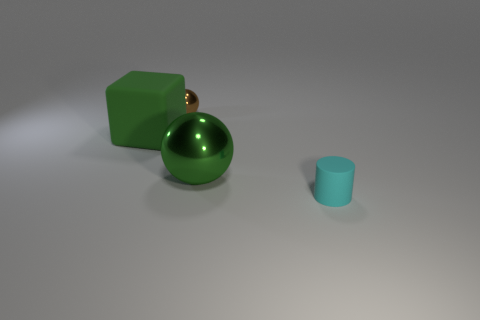There is a large object that is the same shape as the tiny brown shiny thing; what is its color?
Your answer should be very brief. Green. Is the small matte thing the same shape as the big green metal object?
Offer a very short reply. No. The other metal object that is the same shape as the tiny shiny thing is what size?
Your answer should be compact. Large. How many cyan things are the same material as the big ball?
Your response must be concise. 0. How many things are either yellow cylinders or big metal balls?
Offer a terse response. 1. Is there a green block behind the tiny thing that is behind the tiny cyan matte cylinder?
Your response must be concise. No. Are there more small rubber cylinders that are behind the brown metal ball than big spheres in front of the green metal sphere?
Your answer should be compact. No. What is the material of the big object that is the same color as the large ball?
Give a very brief answer. Rubber. What number of small metallic objects are the same color as the large cube?
Your response must be concise. 0. Does the matte thing that is right of the green shiny thing have the same color as the large thing that is behind the green shiny thing?
Your response must be concise. No. 